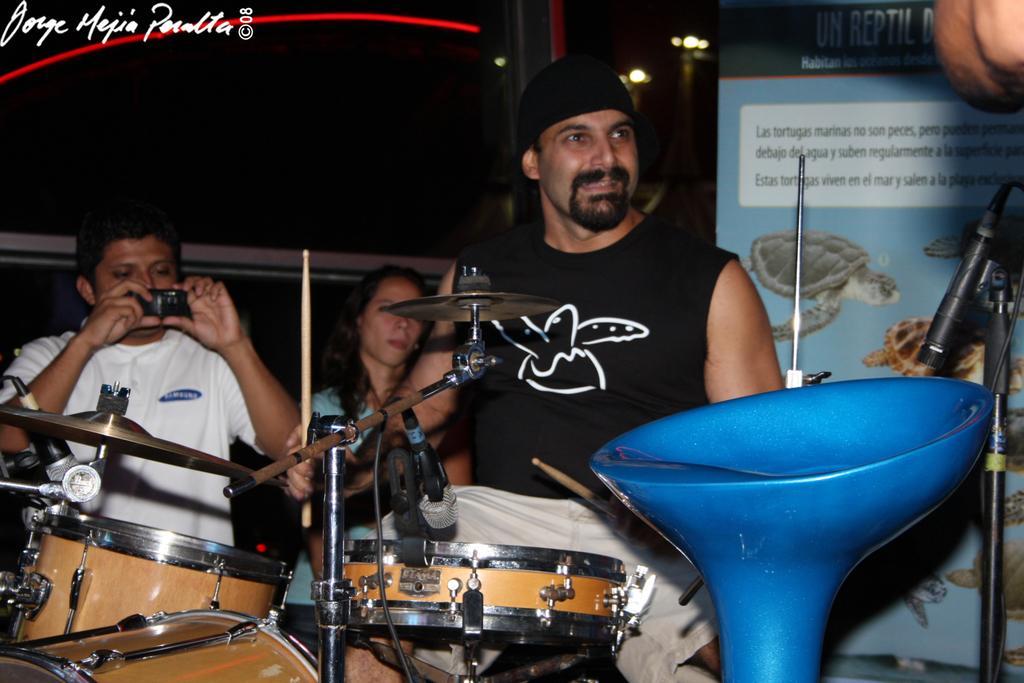Could you give a brief overview of what you see in this image? In this image I can see few people with musical instruments. I can also see a mic. Here I can see a chair and he is holding a camera. 